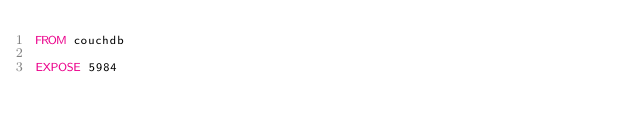<code> <loc_0><loc_0><loc_500><loc_500><_Dockerfile_>FROM couchdb

EXPOSE 5984
</code> 